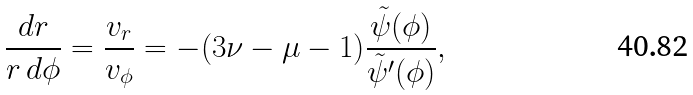Convert formula to latex. <formula><loc_0><loc_0><loc_500><loc_500>\frac { d r } { r \, d \phi } = \frac { v _ { r } } { v _ { \phi } } = - ( 3 \nu - \mu - 1 ) \frac { \tilde { \psi } ( \phi ) } { \tilde { \psi } ^ { \prime } ( \phi ) } ,</formula> 